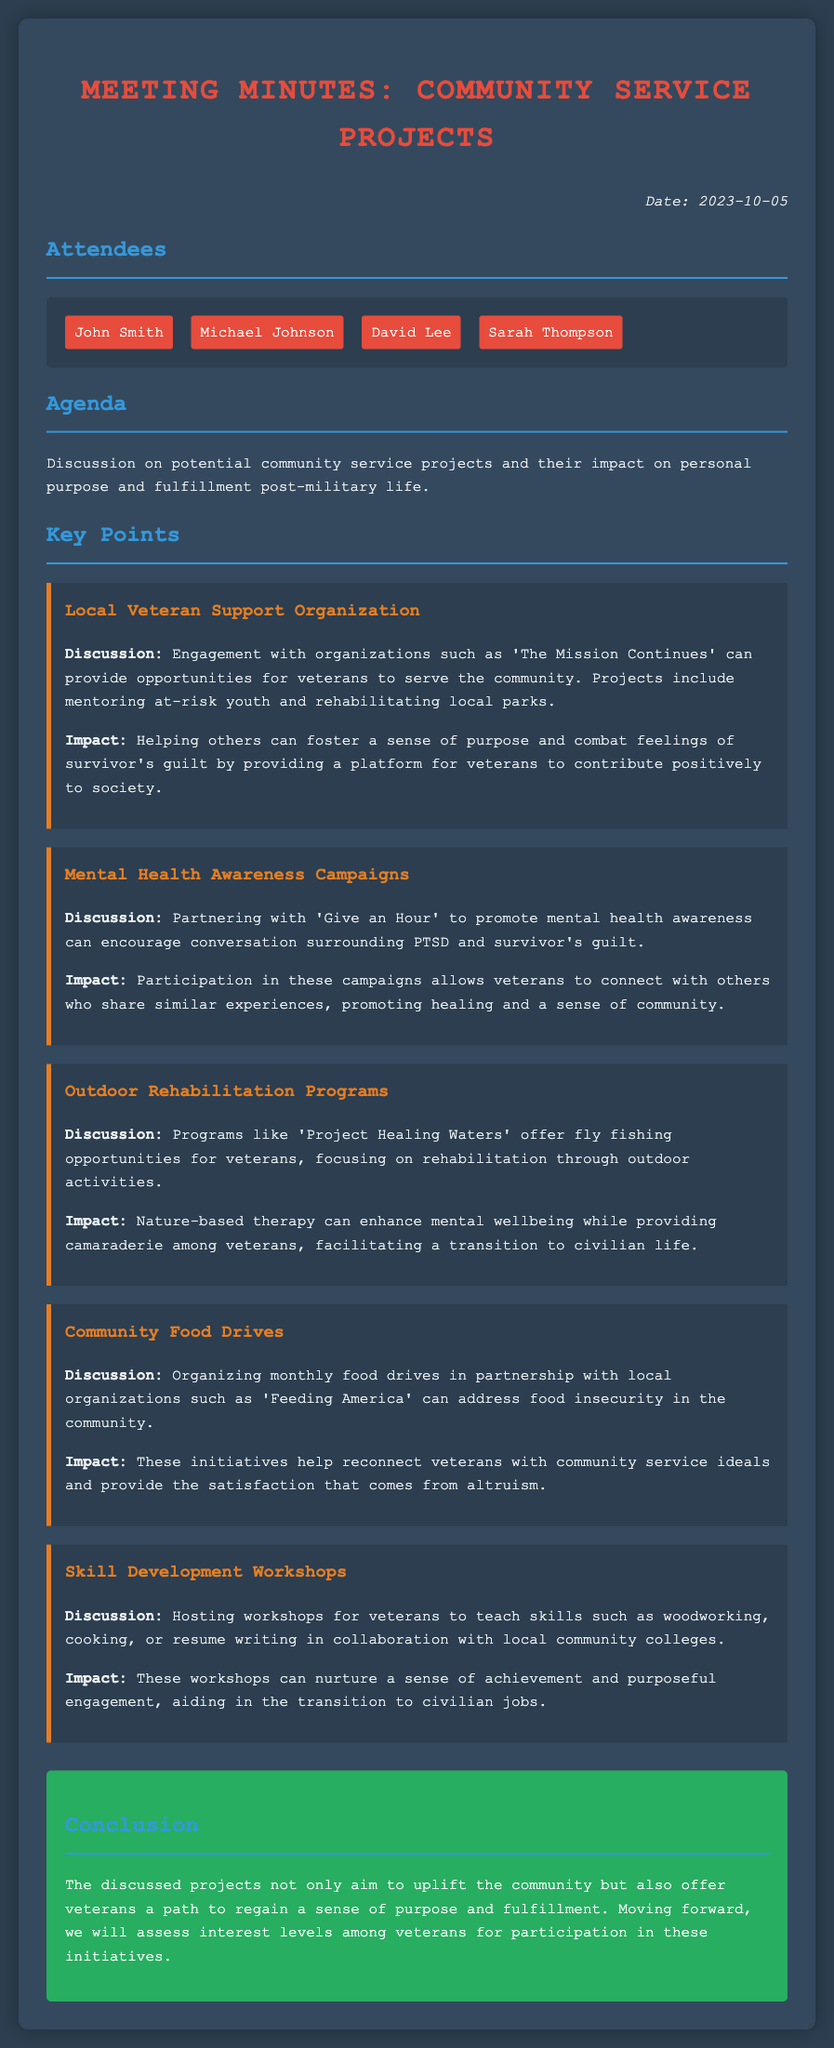What is the date of the meeting? The date of the meeting is clearly stated at the top of the document under the 'Date' section.
Answer: 2023-10-05 Who attended the meeting? The attendees are listed in the 'Attendees' section of the document.
Answer: John Smith, Michael Johnson, David Lee, Sarah Thompson What is one community service project discussed? Each key point in the document outlines a specific community service project discussed in the meeting.
Answer: Local Veteran Support Organization What organization is suggested for mental health awareness? The discussion highlights a specific organization in the section about mental health awareness campaigns.
Answer: Give an Hour What is the main focus of 'Project Healing Waters'? The document specifies the main purpose of the program within the 'Outdoor Rehabilitation Programs' section.
Answer: Rehabilitation through outdoor activities How do community food drives help veterans? The 'Community Food Drives' section explains the impact these initiatives have on veterans.
Answer: Reconnect veterans with community service ideals What is the aim of skill development workshops? The purpose of hosting skill development workshops is outlined in the 'Skill Development Workshops' key point.
Answer: Nurture a sense of achievement What should be assessed moving forward? The conclusion of the document highlights what action will be taken next regarding the discussed projects.
Answer: Interest levels among veterans What color is used for the section titles? The color of the section titles can be found in the style details of the document.
Answer: #3498db 